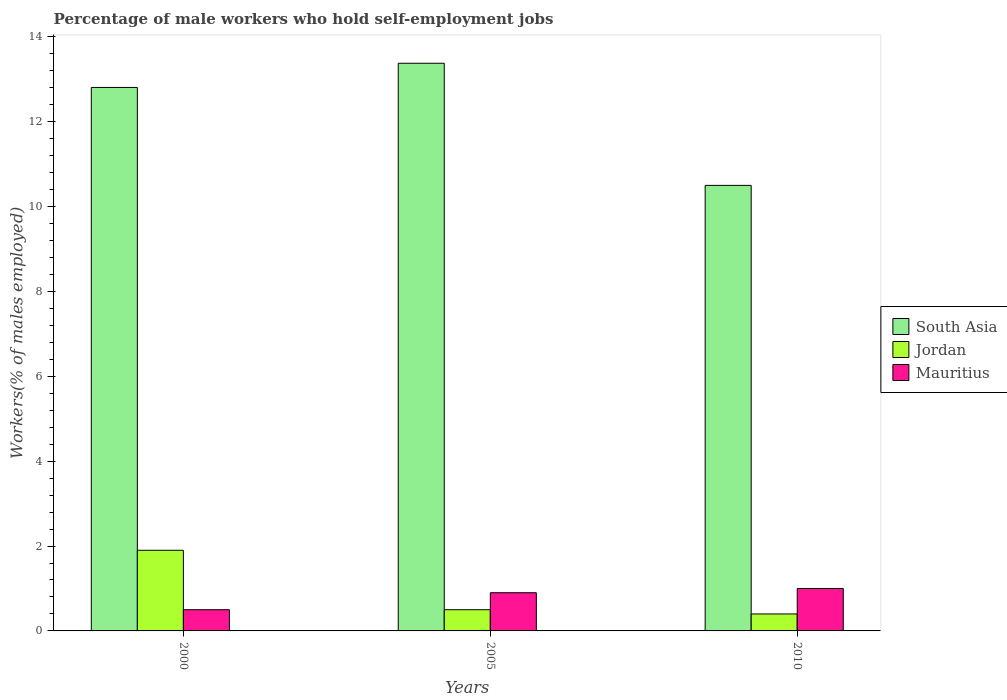How many groups of bars are there?
Ensure brevity in your answer.  3. Are the number of bars per tick equal to the number of legend labels?
Provide a short and direct response. Yes. How many bars are there on the 1st tick from the left?
Offer a very short reply. 3. How many bars are there on the 2nd tick from the right?
Your answer should be compact. 3. What is the label of the 3rd group of bars from the left?
Your answer should be very brief. 2010. In how many cases, is the number of bars for a given year not equal to the number of legend labels?
Your answer should be very brief. 0. Across all years, what is the maximum percentage of self-employed male workers in Mauritius?
Give a very brief answer. 1. Across all years, what is the minimum percentage of self-employed male workers in South Asia?
Provide a succinct answer. 10.5. In which year was the percentage of self-employed male workers in Jordan maximum?
Offer a terse response. 2000. In which year was the percentage of self-employed male workers in South Asia minimum?
Offer a terse response. 2010. What is the total percentage of self-employed male workers in Jordan in the graph?
Give a very brief answer. 2.8. What is the difference between the percentage of self-employed male workers in Mauritius in 2005 and that in 2010?
Provide a short and direct response. -0.1. What is the difference between the percentage of self-employed male workers in Mauritius in 2000 and the percentage of self-employed male workers in South Asia in 2010?
Provide a short and direct response. -10. What is the average percentage of self-employed male workers in Mauritius per year?
Provide a short and direct response. 0.8. In the year 2000, what is the difference between the percentage of self-employed male workers in Mauritius and percentage of self-employed male workers in South Asia?
Keep it short and to the point. -12.31. In how many years, is the percentage of self-employed male workers in Mauritius greater than 13.2 %?
Give a very brief answer. 0. What is the ratio of the percentage of self-employed male workers in South Asia in 2000 to that in 2005?
Provide a short and direct response. 0.96. What is the difference between the highest and the second highest percentage of self-employed male workers in Jordan?
Provide a succinct answer. 1.4. What is the difference between the highest and the lowest percentage of self-employed male workers in Jordan?
Ensure brevity in your answer.  1.5. Is the sum of the percentage of self-employed male workers in Mauritius in 2005 and 2010 greater than the maximum percentage of self-employed male workers in Jordan across all years?
Provide a succinct answer. Yes. How many years are there in the graph?
Provide a short and direct response. 3. What is the difference between two consecutive major ticks on the Y-axis?
Keep it short and to the point. 2. Does the graph contain any zero values?
Your answer should be compact. No. Does the graph contain grids?
Offer a terse response. No. Where does the legend appear in the graph?
Offer a terse response. Center right. How many legend labels are there?
Provide a succinct answer. 3. What is the title of the graph?
Keep it short and to the point. Percentage of male workers who hold self-employment jobs. Does "Sub-Saharan Africa (developing only)" appear as one of the legend labels in the graph?
Keep it short and to the point. No. What is the label or title of the X-axis?
Offer a very short reply. Years. What is the label or title of the Y-axis?
Keep it short and to the point. Workers(% of males employed). What is the Workers(% of males employed) of South Asia in 2000?
Ensure brevity in your answer.  12.81. What is the Workers(% of males employed) of Jordan in 2000?
Ensure brevity in your answer.  1.9. What is the Workers(% of males employed) of South Asia in 2005?
Make the answer very short. 13.38. What is the Workers(% of males employed) of Jordan in 2005?
Offer a very short reply. 0.5. What is the Workers(% of males employed) of Mauritius in 2005?
Ensure brevity in your answer.  0.9. What is the Workers(% of males employed) in South Asia in 2010?
Provide a short and direct response. 10.5. What is the Workers(% of males employed) of Jordan in 2010?
Provide a succinct answer. 0.4. What is the Workers(% of males employed) of Mauritius in 2010?
Make the answer very short. 1. Across all years, what is the maximum Workers(% of males employed) in South Asia?
Your answer should be compact. 13.38. Across all years, what is the maximum Workers(% of males employed) of Jordan?
Provide a short and direct response. 1.9. Across all years, what is the minimum Workers(% of males employed) in South Asia?
Provide a succinct answer. 10.5. Across all years, what is the minimum Workers(% of males employed) in Jordan?
Provide a short and direct response. 0.4. Across all years, what is the minimum Workers(% of males employed) in Mauritius?
Your response must be concise. 0.5. What is the total Workers(% of males employed) in South Asia in the graph?
Provide a succinct answer. 36.68. What is the total Workers(% of males employed) in Jordan in the graph?
Provide a short and direct response. 2.8. What is the total Workers(% of males employed) in Mauritius in the graph?
Your response must be concise. 2.4. What is the difference between the Workers(% of males employed) in South Asia in 2000 and that in 2005?
Keep it short and to the point. -0.57. What is the difference between the Workers(% of males employed) in Mauritius in 2000 and that in 2005?
Ensure brevity in your answer.  -0.4. What is the difference between the Workers(% of males employed) of South Asia in 2000 and that in 2010?
Your answer should be compact. 2.31. What is the difference between the Workers(% of males employed) in Jordan in 2000 and that in 2010?
Keep it short and to the point. 1.5. What is the difference between the Workers(% of males employed) of Mauritius in 2000 and that in 2010?
Ensure brevity in your answer.  -0.5. What is the difference between the Workers(% of males employed) of South Asia in 2005 and that in 2010?
Offer a terse response. 2.88. What is the difference between the Workers(% of males employed) in Mauritius in 2005 and that in 2010?
Your response must be concise. -0.1. What is the difference between the Workers(% of males employed) of South Asia in 2000 and the Workers(% of males employed) of Jordan in 2005?
Your answer should be very brief. 12.31. What is the difference between the Workers(% of males employed) of South Asia in 2000 and the Workers(% of males employed) of Mauritius in 2005?
Provide a succinct answer. 11.91. What is the difference between the Workers(% of males employed) in Jordan in 2000 and the Workers(% of males employed) in Mauritius in 2005?
Ensure brevity in your answer.  1. What is the difference between the Workers(% of males employed) in South Asia in 2000 and the Workers(% of males employed) in Jordan in 2010?
Offer a very short reply. 12.41. What is the difference between the Workers(% of males employed) in South Asia in 2000 and the Workers(% of males employed) in Mauritius in 2010?
Make the answer very short. 11.81. What is the difference between the Workers(% of males employed) of South Asia in 2005 and the Workers(% of males employed) of Jordan in 2010?
Make the answer very short. 12.98. What is the difference between the Workers(% of males employed) in South Asia in 2005 and the Workers(% of males employed) in Mauritius in 2010?
Provide a short and direct response. 12.38. What is the difference between the Workers(% of males employed) of Jordan in 2005 and the Workers(% of males employed) of Mauritius in 2010?
Your answer should be very brief. -0.5. What is the average Workers(% of males employed) of South Asia per year?
Your answer should be compact. 12.23. What is the average Workers(% of males employed) in Jordan per year?
Give a very brief answer. 0.93. What is the average Workers(% of males employed) in Mauritius per year?
Provide a short and direct response. 0.8. In the year 2000, what is the difference between the Workers(% of males employed) of South Asia and Workers(% of males employed) of Jordan?
Your response must be concise. 10.91. In the year 2000, what is the difference between the Workers(% of males employed) of South Asia and Workers(% of males employed) of Mauritius?
Your answer should be compact. 12.31. In the year 2000, what is the difference between the Workers(% of males employed) of Jordan and Workers(% of males employed) of Mauritius?
Provide a succinct answer. 1.4. In the year 2005, what is the difference between the Workers(% of males employed) in South Asia and Workers(% of males employed) in Jordan?
Provide a short and direct response. 12.88. In the year 2005, what is the difference between the Workers(% of males employed) in South Asia and Workers(% of males employed) in Mauritius?
Offer a terse response. 12.48. In the year 2010, what is the difference between the Workers(% of males employed) in South Asia and Workers(% of males employed) in Jordan?
Offer a terse response. 10.1. In the year 2010, what is the difference between the Workers(% of males employed) in South Asia and Workers(% of males employed) in Mauritius?
Your answer should be very brief. 9.5. What is the ratio of the Workers(% of males employed) in South Asia in 2000 to that in 2005?
Ensure brevity in your answer.  0.96. What is the ratio of the Workers(% of males employed) in Jordan in 2000 to that in 2005?
Make the answer very short. 3.8. What is the ratio of the Workers(% of males employed) in Mauritius in 2000 to that in 2005?
Provide a short and direct response. 0.56. What is the ratio of the Workers(% of males employed) of South Asia in 2000 to that in 2010?
Provide a succinct answer. 1.22. What is the ratio of the Workers(% of males employed) of Jordan in 2000 to that in 2010?
Keep it short and to the point. 4.75. What is the ratio of the Workers(% of males employed) in Mauritius in 2000 to that in 2010?
Offer a very short reply. 0.5. What is the ratio of the Workers(% of males employed) in South Asia in 2005 to that in 2010?
Your answer should be compact. 1.27. What is the ratio of the Workers(% of males employed) in Jordan in 2005 to that in 2010?
Provide a succinct answer. 1.25. What is the ratio of the Workers(% of males employed) in Mauritius in 2005 to that in 2010?
Make the answer very short. 0.9. What is the difference between the highest and the second highest Workers(% of males employed) in South Asia?
Ensure brevity in your answer.  0.57. What is the difference between the highest and the second highest Workers(% of males employed) in Jordan?
Ensure brevity in your answer.  1.4. What is the difference between the highest and the lowest Workers(% of males employed) in South Asia?
Your answer should be very brief. 2.88. What is the difference between the highest and the lowest Workers(% of males employed) in Jordan?
Your response must be concise. 1.5. 